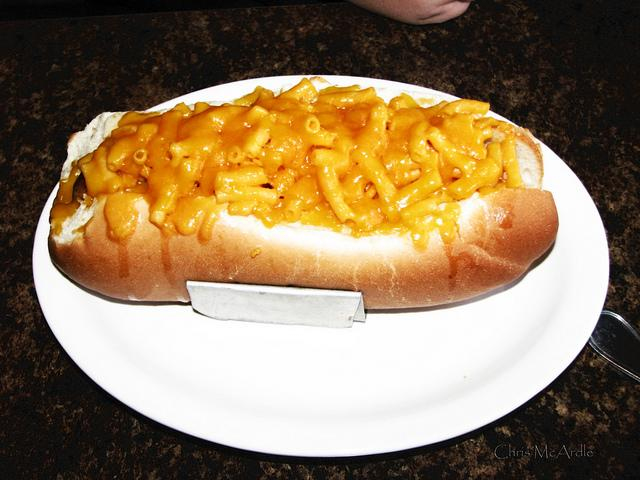What type of food is on top of the bread?

Choices:
A) fruit
B) vegetables
C) noodles
D) meat noodles 